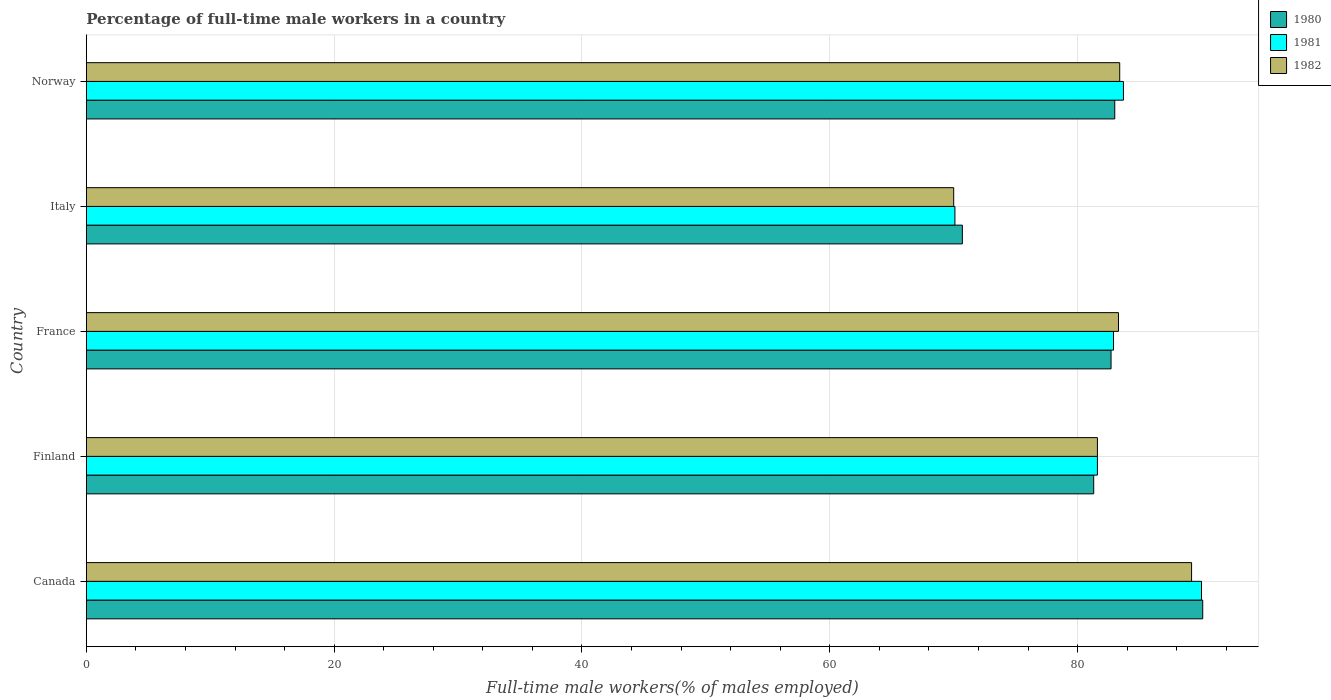How many groups of bars are there?
Make the answer very short. 5. Are the number of bars per tick equal to the number of legend labels?
Your response must be concise. Yes. Are the number of bars on each tick of the Y-axis equal?
Provide a short and direct response. Yes. How many bars are there on the 5th tick from the bottom?
Ensure brevity in your answer.  3. What is the label of the 1st group of bars from the top?
Provide a succinct answer. Norway. What is the percentage of full-time male workers in 1982 in Canada?
Give a very brief answer. 89.2. Across all countries, what is the maximum percentage of full-time male workers in 1980?
Your response must be concise. 90.1. Across all countries, what is the minimum percentage of full-time male workers in 1980?
Give a very brief answer. 70.7. What is the total percentage of full-time male workers in 1980 in the graph?
Your answer should be compact. 407.8. What is the difference between the percentage of full-time male workers in 1982 in France and that in Norway?
Ensure brevity in your answer.  -0.1. What is the difference between the percentage of full-time male workers in 1982 in Italy and the percentage of full-time male workers in 1980 in Finland?
Your answer should be very brief. -11.3. What is the average percentage of full-time male workers in 1982 per country?
Offer a very short reply. 81.5. What is the difference between the percentage of full-time male workers in 1981 and percentage of full-time male workers in 1982 in France?
Provide a short and direct response. -0.4. What is the ratio of the percentage of full-time male workers in 1980 in Canada to that in Finland?
Ensure brevity in your answer.  1.11. What is the difference between the highest and the second highest percentage of full-time male workers in 1981?
Give a very brief answer. 6.3. What is the difference between the highest and the lowest percentage of full-time male workers in 1980?
Provide a short and direct response. 19.4. Is the sum of the percentage of full-time male workers in 1981 in Canada and France greater than the maximum percentage of full-time male workers in 1980 across all countries?
Offer a very short reply. Yes. What does the 2nd bar from the top in France represents?
Make the answer very short. 1981. Is it the case that in every country, the sum of the percentage of full-time male workers in 1982 and percentage of full-time male workers in 1981 is greater than the percentage of full-time male workers in 1980?
Ensure brevity in your answer.  Yes. How many bars are there?
Give a very brief answer. 15. How many countries are there in the graph?
Keep it short and to the point. 5. What is the difference between two consecutive major ticks on the X-axis?
Offer a terse response. 20. Does the graph contain grids?
Offer a terse response. Yes. What is the title of the graph?
Provide a succinct answer. Percentage of full-time male workers in a country. Does "1990" appear as one of the legend labels in the graph?
Give a very brief answer. No. What is the label or title of the X-axis?
Offer a very short reply. Full-time male workers(% of males employed). What is the Full-time male workers(% of males employed) in 1980 in Canada?
Your answer should be very brief. 90.1. What is the Full-time male workers(% of males employed) of 1982 in Canada?
Give a very brief answer. 89.2. What is the Full-time male workers(% of males employed) of 1980 in Finland?
Your response must be concise. 81.3. What is the Full-time male workers(% of males employed) of 1981 in Finland?
Your answer should be very brief. 81.6. What is the Full-time male workers(% of males employed) in 1982 in Finland?
Make the answer very short. 81.6. What is the Full-time male workers(% of males employed) in 1980 in France?
Your answer should be very brief. 82.7. What is the Full-time male workers(% of males employed) in 1981 in France?
Offer a terse response. 82.9. What is the Full-time male workers(% of males employed) of 1982 in France?
Your answer should be very brief. 83.3. What is the Full-time male workers(% of males employed) of 1980 in Italy?
Your answer should be very brief. 70.7. What is the Full-time male workers(% of males employed) in 1981 in Italy?
Give a very brief answer. 70.1. What is the Full-time male workers(% of males employed) in 1982 in Italy?
Ensure brevity in your answer.  70. What is the Full-time male workers(% of males employed) in 1980 in Norway?
Keep it short and to the point. 83. What is the Full-time male workers(% of males employed) in 1981 in Norway?
Offer a terse response. 83.7. What is the Full-time male workers(% of males employed) in 1982 in Norway?
Your response must be concise. 83.4. Across all countries, what is the maximum Full-time male workers(% of males employed) of 1980?
Ensure brevity in your answer.  90.1. Across all countries, what is the maximum Full-time male workers(% of males employed) in 1981?
Keep it short and to the point. 90. Across all countries, what is the maximum Full-time male workers(% of males employed) of 1982?
Your answer should be compact. 89.2. Across all countries, what is the minimum Full-time male workers(% of males employed) in 1980?
Your answer should be compact. 70.7. Across all countries, what is the minimum Full-time male workers(% of males employed) of 1981?
Give a very brief answer. 70.1. Across all countries, what is the minimum Full-time male workers(% of males employed) of 1982?
Offer a very short reply. 70. What is the total Full-time male workers(% of males employed) of 1980 in the graph?
Provide a short and direct response. 407.8. What is the total Full-time male workers(% of males employed) in 1981 in the graph?
Provide a succinct answer. 408.3. What is the total Full-time male workers(% of males employed) in 1982 in the graph?
Provide a short and direct response. 407.5. What is the difference between the Full-time male workers(% of males employed) in 1980 in Canada and that in Finland?
Your answer should be compact. 8.8. What is the difference between the Full-time male workers(% of males employed) in 1981 in Canada and that in Finland?
Your answer should be very brief. 8.4. What is the difference between the Full-time male workers(% of males employed) in 1982 in Canada and that in Finland?
Keep it short and to the point. 7.6. What is the difference between the Full-time male workers(% of males employed) in 1980 in Canada and that in France?
Ensure brevity in your answer.  7.4. What is the difference between the Full-time male workers(% of males employed) of 1981 in Canada and that in France?
Provide a succinct answer. 7.1. What is the difference between the Full-time male workers(% of males employed) in 1982 in Canada and that in France?
Keep it short and to the point. 5.9. What is the difference between the Full-time male workers(% of males employed) in 1980 in Canada and that in Italy?
Your answer should be very brief. 19.4. What is the difference between the Full-time male workers(% of males employed) in 1980 in Canada and that in Norway?
Your response must be concise. 7.1. What is the difference between the Full-time male workers(% of males employed) of 1981 in Canada and that in Norway?
Make the answer very short. 6.3. What is the difference between the Full-time male workers(% of males employed) of 1980 in Finland and that in France?
Offer a very short reply. -1.4. What is the difference between the Full-time male workers(% of males employed) in 1981 in Finland and that in France?
Provide a succinct answer. -1.3. What is the difference between the Full-time male workers(% of males employed) in 1982 in Finland and that in France?
Offer a terse response. -1.7. What is the difference between the Full-time male workers(% of males employed) of 1980 in Finland and that in Italy?
Offer a very short reply. 10.6. What is the difference between the Full-time male workers(% of males employed) in 1982 in Finland and that in Italy?
Provide a short and direct response. 11.6. What is the difference between the Full-time male workers(% of males employed) of 1980 in Finland and that in Norway?
Make the answer very short. -1.7. What is the difference between the Full-time male workers(% of males employed) of 1981 in Finland and that in Norway?
Keep it short and to the point. -2.1. What is the difference between the Full-time male workers(% of males employed) of 1982 in Finland and that in Norway?
Offer a terse response. -1.8. What is the difference between the Full-time male workers(% of males employed) of 1981 in France and that in Italy?
Provide a succinct answer. 12.8. What is the difference between the Full-time male workers(% of males employed) in 1982 in France and that in Italy?
Ensure brevity in your answer.  13.3. What is the difference between the Full-time male workers(% of males employed) in 1980 in France and that in Norway?
Offer a terse response. -0.3. What is the difference between the Full-time male workers(% of males employed) in 1981 in Italy and that in Norway?
Offer a terse response. -13.6. What is the difference between the Full-time male workers(% of males employed) in 1982 in Italy and that in Norway?
Your response must be concise. -13.4. What is the difference between the Full-time male workers(% of males employed) of 1980 in Canada and the Full-time male workers(% of males employed) of 1981 in Finland?
Your answer should be very brief. 8.5. What is the difference between the Full-time male workers(% of males employed) of 1980 in Canada and the Full-time male workers(% of males employed) of 1981 in France?
Ensure brevity in your answer.  7.2. What is the difference between the Full-time male workers(% of males employed) in 1980 in Canada and the Full-time male workers(% of males employed) in 1982 in France?
Your answer should be very brief. 6.8. What is the difference between the Full-time male workers(% of males employed) of 1980 in Canada and the Full-time male workers(% of males employed) of 1981 in Italy?
Offer a very short reply. 20. What is the difference between the Full-time male workers(% of males employed) in 1980 in Canada and the Full-time male workers(% of males employed) in 1982 in Italy?
Ensure brevity in your answer.  20.1. What is the difference between the Full-time male workers(% of males employed) of 1981 in Canada and the Full-time male workers(% of males employed) of 1982 in Norway?
Your answer should be compact. 6.6. What is the difference between the Full-time male workers(% of males employed) of 1981 in Finland and the Full-time male workers(% of males employed) of 1982 in Italy?
Give a very brief answer. 11.6. What is the difference between the Full-time male workers(% of males employed) of 1980 in Finland and the Full-time male workers(% of males employed) of 1981 in Norway?
Provide a short and direct response. -2.4. What is the difference between the Full-time male workers(% of males employed) in 1980 in Finland and the Full-time male workers(% of males employed) in 1982 in Norway?
Make the answer very short. -2.1. What is the difference between the Full-time male workers(% of males employed) in 1980 in France and the Full-time male workers(% of males employed) in 1981 in Italy?
Give a very brief answer. 12.6. What is the difference between the Full-time male workers(% of males employed) of 1980 in France and the Full-time male workers(% of males employed) of 1982 in Norway?
Your answer should be very brief. -0.7. What is the difference between the Full-time male workers(% of males employed) in 1980 in Italy and the Full-time male workers(% of males employed) in 1981 in Norway?
Offer a terse response. -13. What is the difference between the Full-time male workers(% of males employed) in 1981 in Italy and the Full-time male workers(% of males employed) in 1982 in Norway?
Your answer should be very brief. -13.3. What is the average Full-time male workers(% of males employed) of 1980 per country?
Keep it short and to the point. 81.56. What is the average Full-time male workers(% of males employed) of 1981 per country?
Ensure brevity in your answer.  81.66. What is the average Full-time male workers(% of males employed) in 1982 per country?
Your response must be concise. 81.5. What is the difference between the Full-time male workers(% of males employed) in 1980 and Full-time male workers(% of males employed) in 1982 in Finland?
Offer a terse response. -0.3. What is the difference between the Full-time male workers(% of males employed) in 1981 and Full-time male workers(% of males employed) in 1982 in Finland?
Offer a terse response. 0. What is the difference between the Full-time male workers(% of males employed) in 1980 and Full-time male workers(% of males employed) in 1981 in France?
Your answer should be very brief. -0.2. What is the difference between the Full-time male workers(% of males employed) of 1980 and Full-time male workers(% of males employed) of 1982 in France?
Offer a very short reply. -0.6. What is the difference between the Full-time male workers(% of males employed) in 1980 and Full-time male workers(% of males employed) in 1982 in Italy?
Offer a very short reply. 0.7. What is the difference between the Full-time male workers(% of males employed) in 1980 and Full-time male workers(% of males employed) in 1982 in Norway?
Your answer should be compact. -0.4. What is the difference between the Full-time male workers(% of males employed) of 1981 and Full-time male workers(% of males employed) of 1982 in Norway?
Provide a succinct answer. 0.3. What is the ratio of the Full-time male workers(% of males employed) of 1980 in Canada to that in Finland?
Provide a succinct answer. 1.11. What is the ratio of the Full-time male workers(% of males employed) of 1981 in Canada to that in Finland?
Make the answer very short. 1.1. What is the ratio of the Full-time male workers(% of males employed) in 1982 in Canada to that in Finland?
Ensure brevity in your answer.  1.09. What is the ratio of the Full-time male workers(% of males employed) of 1980 in Canada to that in France?
Ensure brevity in your answer.  1.09. What is the ratio of the Full-time male workers(% of males employed) of 1981 in Canada to that in France?
Give a very brief answer. 1.09. What is the ratio of the Full-time male workers(% of males employed) of 1982 in Canada to that in France?
Your answer should be very brief. 1.07. What is the ratio of the Full-time male workers(% of males employed) in 1980 in Canada to that in Italy?
Ensure brevity in your answer.  1.27. What is the ratio of the Full-time male workers(% of males employed) of 1981 in Canada to that in Italy?
Your answer should be very brief. 1.28. What is the ratio of the Full-time male workers(% of males employed) of 1982 in Canada to that in Italy?
Your answer should be compact. 1.27. What is the ratio of the Full-time male workers(% of males employed) of 1980 in Canada to that in Norway?
Your response must be concise. 1.09. What is the ratio of the Full-time male workers(% of males employed) in 1981 in Canada to that in Norway?
Offer a very short reply. 1.08. What is the ratio of the Full-time male workers(% of males employed) of 1982 in Canada to that in Norway?
Make the answer very short. 1.07. What is the ratio of the Full-time male workers(% of males employed) of 1980 in Finland to that in France?
Your answer should be compact. 0.98. What is the ratio of the Full-time male workers(% of males employed) of 1981 in Finland to that in France?
Ensure brevity in your answer.  0.98. What is the ratio of the Full-time male workers(% of males employed) of 1982 in Finland to that in France?
Your answer should be very brief. 0.98. What is the ratio of the Full-time male workers(% of males employed) of 1980 in Finland to that in Italy?
Give a very brief answer. 1.15. What is the ratio of the Full-time male workers(% of males employed) in 1981 in Finland to that in Italy?
Keep it short and to the point. 1.16. What is the ratio of the Full-time male workers(% of males employed) in 1982 in Finland to that in Italy?
Your response must be concise. 1.17. What is the ratio of the Full-time male workers(% of males employed) in 1980 in Finland to that in Norway?
Offer a terse response. 0.98. What is the ratio of the Full-time male workers(% of males employed) of 1981 in Finland to that in Norway?
Provide a succinct answer. 0.97. What is the ratio of the Full-time male workers(% of males employed) of 1982 in Finland to that in Norway?
Offer a terse response. 0.98. What is the ratio of the Full-time male workers(% of males employed) of 1980 in France to that in Italy?
Your answer should be very brief. 1.17. What is the ratio of the Full-time male workers(% of males employed) of 1981 in France to that in Italy?
Provide a succinct answer. 1.18. What is the ratio of the Full-time male workers(% of males employed) in 1982 in France to that in Italy?
Your answer should be compact. 1.19. What is the ratio of the Full-time male workers(% of males employed) of 1981 in France to that in Norway?
Keep it short and to the point. 0.99. What is the ratio of the Full-time male workers(% of males employed) of 1982 in France to that in Norway?
Offer a terse response. 1. What is the ratio of the Full-time male workers(% of males employed) in 1980 in Italy to that in Norway?
Give a very brief answer. 0.85. What is the ratio of the Full-time male workers(% of males employed) of 1981 in Italy to that in Norway?
Your answer should be very brief. 0.84. What is the ratio of the Full-time male workers(% of males employed) of 1982 in Italy to that in Norway?
Provide a short and direct response. 0.84. What is the difference between the highest and the lowest Full-time male workers(% of males employed) of 1980?
Your answer should be very brief. 19.4. What is the difference between the highest and the lowest Full-time male workers(% of males employed) in 1981?
Your answer should be compact. 19.9. 